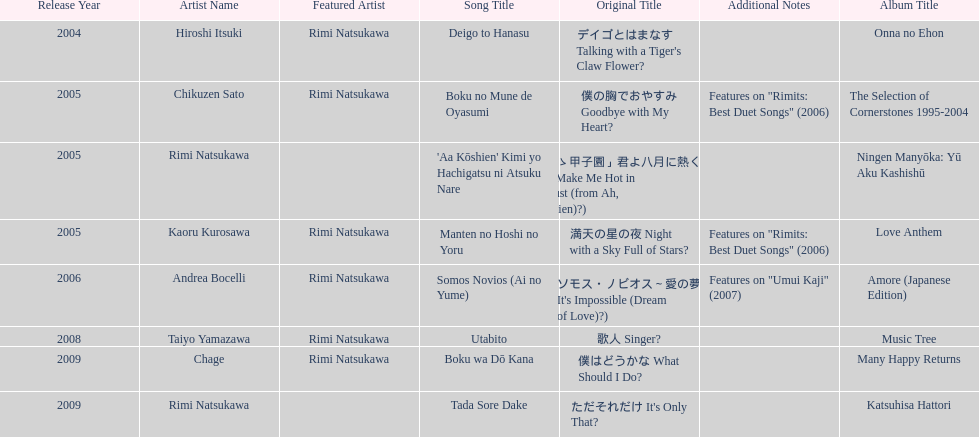What song was this artist on after utabito? Boku wa Dō Kana. Write the full table. {'header': ['Release Year', 'Artist Name', 'Featured Artist', 'Song Title', 'Original Title', 'Additional Notes', 'Album Title'], 'rows': [['2004', 'Hiroshi Itsuki', 'Rimi Natsukawa', 'Deigo to Hanasu', "デイゴとはまなす Talking with a Tiger's Claw Flower?", '', 'Onna no Ehon'], ['2005', 'Chikuzen Sato', 'Rimi Natsukawa', 'Boku no Mune de Oyasumi', '僕の胸でおやすみ Goodbye with My Heart?', 'Features on "Rimits: Best Duet Songs" (2006)', 'The Selection of Cornerstones 1995-2004'], ['2005', 'Rimi Natsukawa', '', "'Aa Kōshien' Kimi yo Hachigatsu ni Atsuku Nare", '「あゝ甲子園」君よ八月に熱くなれ You Make Me Hot in August (from Ah, Kōshien)?)', '', 'Ningen Manyōka: Yū Aku Kashishū'], ['2005', 'Kaoru Kurosawa', 'Rimi Natsukawa', 'Manten no Hoshi no Yoru', '満天の星の夜 Night with a Sky Full of Stars?', 'Features on "Rimits: Best Duet Songs" (2006)', 'Love Anthem'], ['2006', 'Andrea Bocelli', 'Rimi Natsukawa', 'Somos Novios (Ai no Yume)', "ソモス・ノビオス～愛の夢 It's Impossible (Dream of Love)?)", 'Features on "Umui Kaji" (2007)', 'Amore (Japanese Edition)'], ['2008', 'Taiyo Yamazawa', 'Rimi Natsukawa', 'Utabito', '歌人 Singer?', '', 'Music Tree'], ['2009', 'Chage', 'Rimi Natsukawa', 'Boku wa Dō Kana', '僕はどうかな What Should I Do?', '', 'Many Happy Returns'], ['2009', 'Rimi Natsukawa', '', 'Tada Sore Dake', "ただそれだけ It's Only That?", '', 'Katsuhisa Hattori']]} 